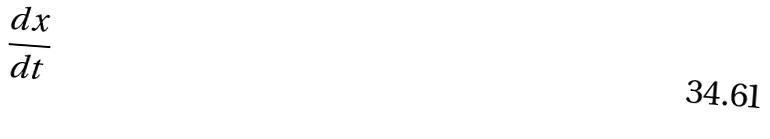Convert formula to latex. <formula><loc_0><loc_0><loc_500><loc_500>\frac { d x } { d t }</formula> 